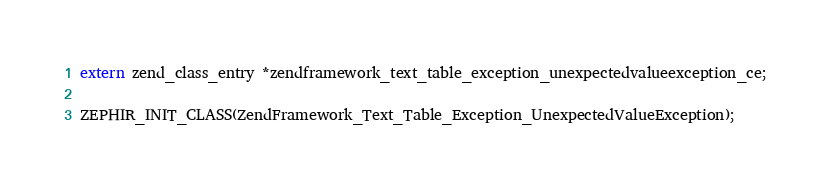<code> <loc_0><loc_0><loc_500><loc_500><_C_>
extern zend_class_entry *zendframework_text_table_exception_unexpectedvalueexception_ce;

ZEPHIR_INIT_CLASS(ZendFramework_Text_Table_Exception_UnexpectedValueException);

</code> 